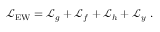<formula> <loc_0><loc_0><loc_500><loc_500>{ \mathcal { L } } _ { E W } = { \mathcal { L } } _ { g } + { \mathcal { L } } _ { f } + { \mathcal { L } } _ { h } + { \mathcal { L } } _ { y } .</formula> 